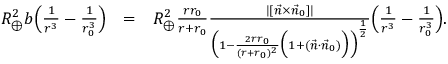<formula> <loc_0><loc_0><loc_500><loc_500>\begin{array} { r l r } { R _ { \oplus } ^ { 2 } b \left ( \frac { 1 } { r ^ { 3 } } - \frac { 1 } { r _ { 0 } ^ { 3 } } \right ) } & { = } & { R _ { \oplus } ^ { 2 } \frac { r r _ { 0 } } { r + r _ { 0 } } \frac { | [ \vec { n } \times \vec { n } _ { 0 } ] | } { \left ( 1 - \frac { 2 r r _ { 0 } } { ( r + r _ { 0 } ) ^ { 2 } } \left ( 1 + ( \vec { n } \cdot \vec { n } _ { 0 } ) \right ) \right ) ^ { \frac { 1 } { 2 } } } \left ( \frac { 1 } { r ^ { 3 } } - \frac { 1 } { r _ { 0 } ^ { 3 } } \right ) . } \end{array}</formula> 